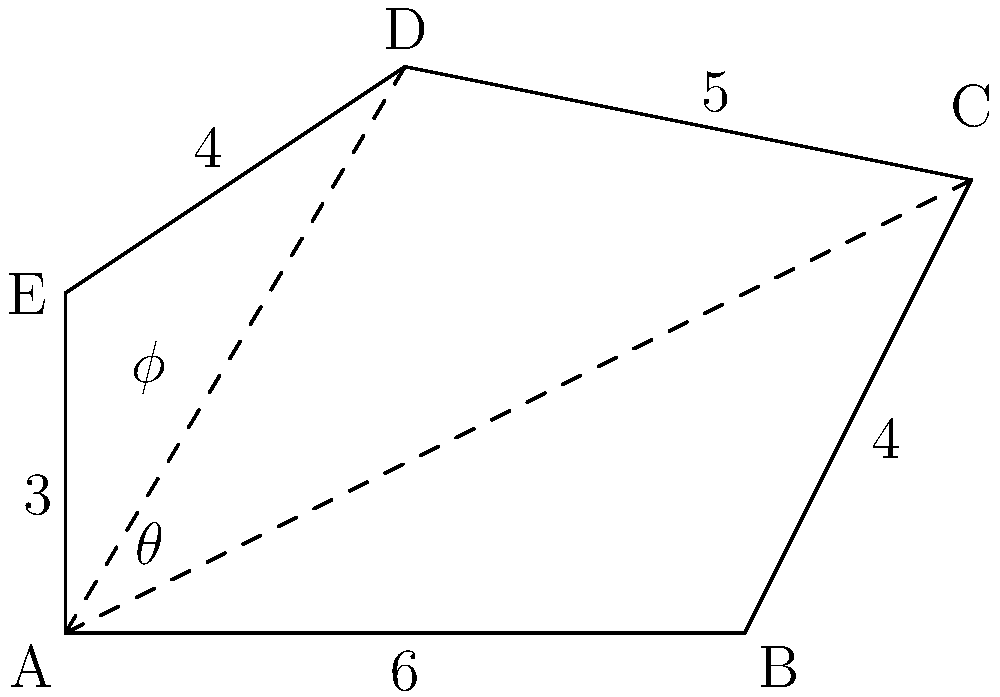In a study on workplace layout and its impact on team collaboration, you're analyzing an irregularly shaped office space. The floor plan forms a pentagon ABCDE with known side lengths: AB = 6 m, BC = 4 m, CD = 5 m, DE = 4 m, and EA = 3 m. Given that angle CAB (θ) is 30° and angle DAE (φ) is 45°, calculate the total area of the office space. How might this layout affect team dynamics and communication patterns? To calculate the area of the irregular pentagon, we'll divide it into three triangles: ABC, ACD, and ADE. We'll then calculate the area of each triangle and sum them up.

1. Triangle ABC:
   We know AB = 6 m and BC = 4 m. We can find AC using the law of cosines:
   $$AC^2 = AB^2 + BC^2 - 2(AB)(BC)\cos(180°-30°)$$
   $$AC^2 = 6^2 + 4^2 - 2(6)(4)\cos(150°)$$
   $$AC^2 = 36 + 16 - 48(-0.866) = 93.568$$
   $$AC = \sqrt{93.568} \approx 9.673 \text{ m}$$

   Area of ABC = $\frac{1}{2}(AB)(BC)\sin(180°-30°) = \frac{1}{2}(6)(4)\sin(150°) = 10.392 \text{ m}^2$

2. Triangle ACD:
   We know AC ≈ 9.673 m and CD = 5 m. We can find angle CAD:
   $$\angle CAD = 180° - 30° - \angle ACD$$
   $$\angle ACD = \arccos(\frac{AC^2 + CD^2 - AD^2}{2(AC)(CD)})$$
   $$\angle ACD = \arccos(\frac{9.673^2 + 5^2 - 7^2}{2(9.673)(5)}) \approx 44.42°$$
   $$\angle CAD = 180° - 30° - 44.42° = 105.58°$$

   Area of ACD = $\frac{1}{2}(AC)(CD)\sin(105.58°) = \frac{1}{2}(9.673)(5)\sin(105.58°) = 23.178 \text{ m}^2$

3. Triangle ADE:
   We know AD = 7 m, DE = 4 m, and angle DAE = 45°.

   Area of ADE = $\frac{1}{2}(AD)(DE)\sin(45°) = \frac{1}{2}(7)(4)\sin(45°) = 9.899 \text{ m}^2$

4. Total area:
   $$\text{Total Area} = \text{Area}_{\triangle ABC} + \text{Area}_{\triangle ACD} + \text{Area}_{\triangle ADE}$$
   $$\text{Total Area} = 10.392 + 23.178 + 9.899 = 43.469 \text{ m}^2$$

This layout, with its irregular shape and varying distances between points, might affect team dynamics by creating natural divisions or clusters within the office. The central area (near point A) could become a hub for communication, while corners might offer more private spaces for focused work or small group discussions.
Answer: 43.469 m² 